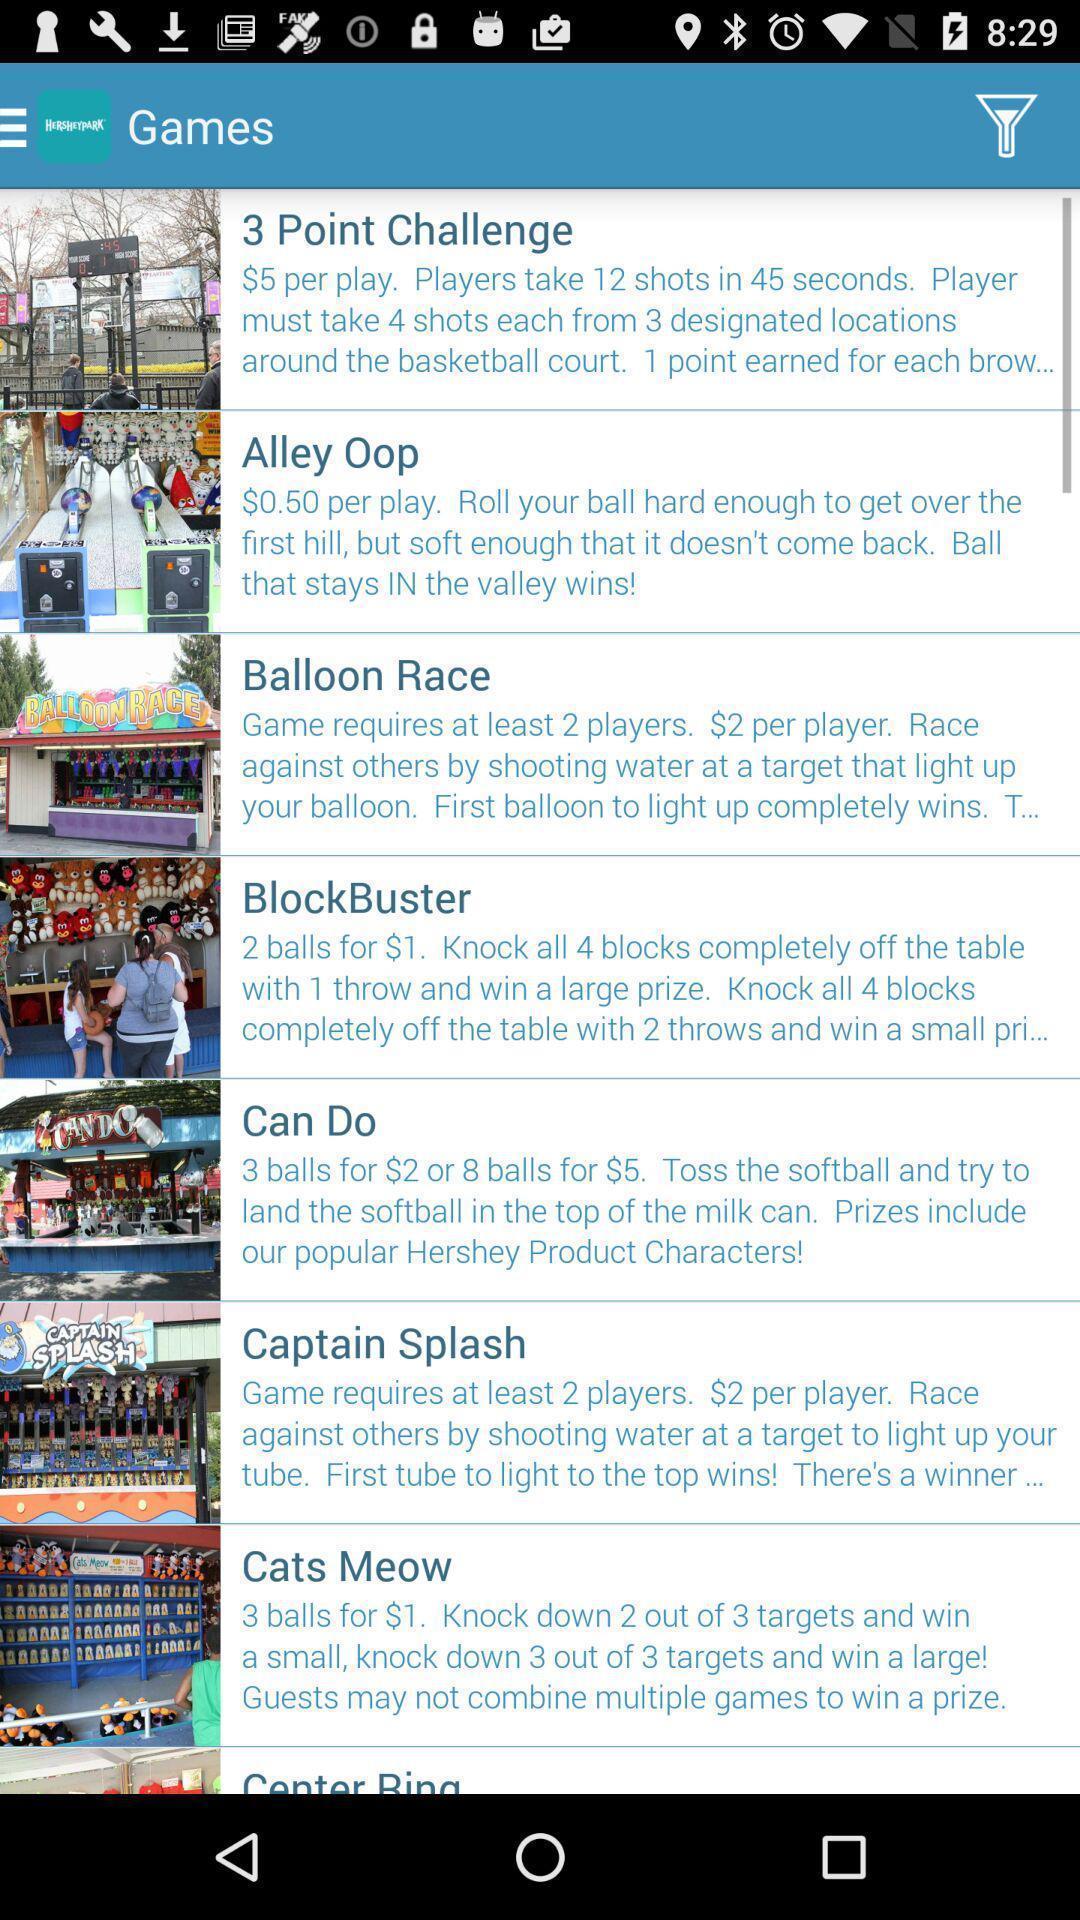Describe the key features of this screenshot. Screen showing games page. 